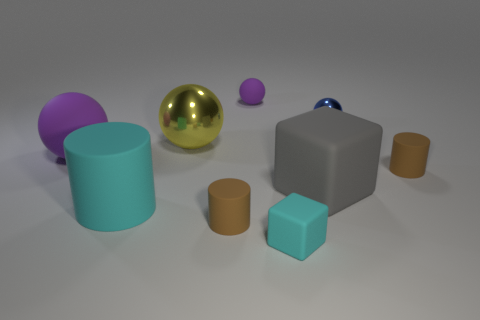Subtract all purple cylinders. How many purple balls are left? 2 Subtract all blue balls. How many balls are left? 3 Subtract all large metallic balls. How many balls are left? 3 Add 1 tiny cubes. How many objects exist? 10 Subtract all cyan balls. Subtract all yellow blocks. How many balls are left? 4 Subtract all cylinders. How many objects are left? 6 Subtract all tiny cyan matte cubes. Subtract all large rubber objects. How many objects are left? 5 Add 8 big cyan matte cylinders. How many big cyan matte cylinders are left? 9 Add 2 small cyan things. How many small cyan things exist? 3 Subtract 0 brown spheres. How many objects are left? 9 